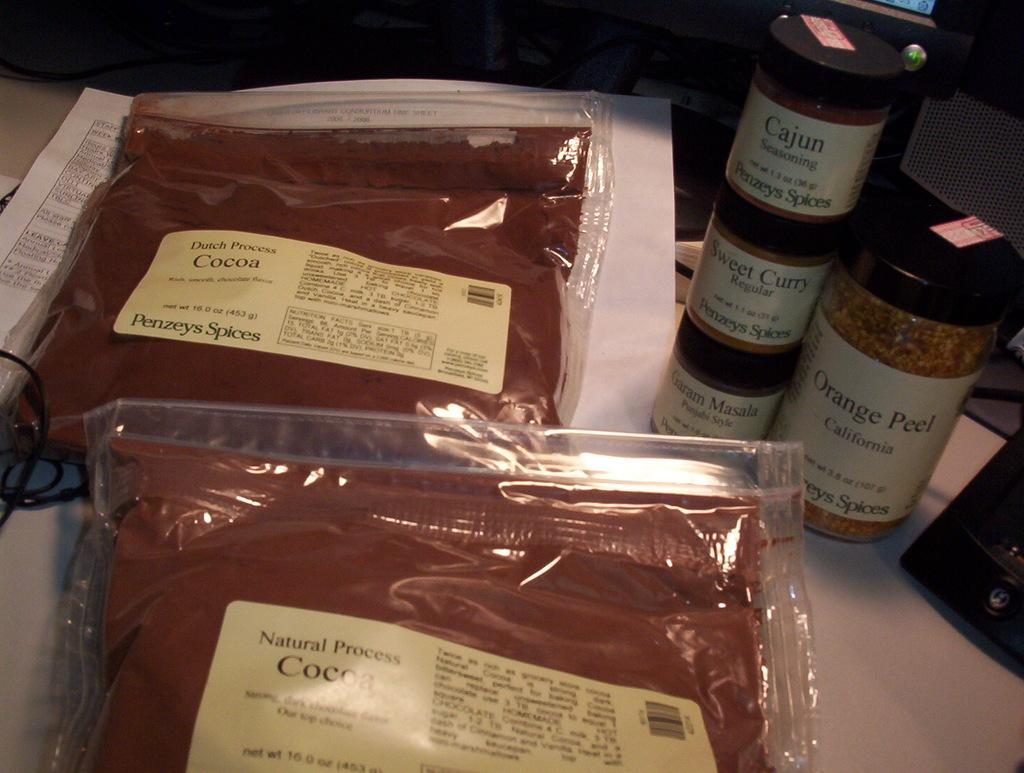<image>
Write a terse but informative summary of the picture. Natural Process cocoa in a pack and seasoning in a bottle 